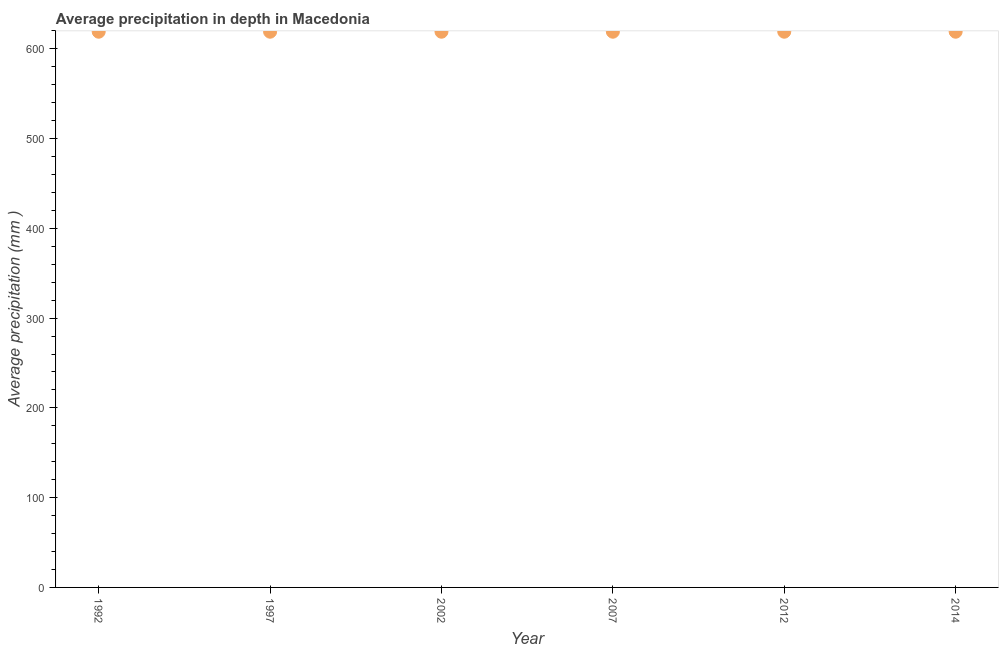What is the average precipitation in depth in 2012?
Offer a very short reply. 619. Across all years, what is the maximum average precipitation in depth?
Make the answer very short. 619. Across all years, what is the minimum average precipitation in depth?
Offer a very short reply. 619. In which year was the average precipitation in depth maximum?
Give a very brief answer. 1992. In which year was the average precipitation in depth minimum?
Your answer should be compact. 1992. What is the sum of the average precipitation in depth?
Make the answer very short. 3714. What is the difference between the average precipitation in depth in 1997 and 2014?
Provide a short and direct response. 0. What is the average average precipitation in depth per year?
Ensure brevity in your answer.  619. What is the median average precipitation in depth?
Provide a succinct answer. 619. In how many years, is the average precipitation in depth greater than 120 mm?
Offer a very short reply. 6. What is the difference between the highest and the second highest average precipitation in depth?
Give a very brief answer. 0. Is the sum of the average precipitation in depth in 1992 and 2012 greater than the maximum average precipitation in depth across all years?
Provide a succinct answer. Yes. What is the difference between the highest and the lowest average precipitation in depth?
Offer a very short reply. 0. In how many years, is the average precipitation in depth greater than the average average precipitation in depth taken over all years?
Your answer should be very brief. 0. Are the values on the major ticks of Y-axis written in scientific E-notation?
Your answer should be very brief. No. Does the graph contain any zero values?
Provide a succinct answer. No. What is the title of the graph?
Your answer should be compact. Average precipitation in depth in Macedonia. What is the label or title of the X-axis?
Provide a succinct answer. Year. What is the label or title of the Y-axis?
Your answer should be very brief. Average precipitation (mm ). What is the Average precipitation (mm ) in 1992?
Your answer should be compact. 619. What is the Average precipitation (mm ) in 1997?
Your answer should be compact. 619. What is the Average precipitation (mm ) in 2002?
Offer a very short reply. 619. What is the Average precipitation (mm ) in 2007?
Your answer should be very brief. 619. What is the Average precipitation (mm ) in 2012?
Offer a very short reply. 619. What is the Average precipitation (mm ) in 2014?
Make the answer very short. 619. What is the difference between the Average precipitation (mm ) in 1992 and 1997?
Your answer should be compact. 0. What is the difference between the Average precipitation (mm ) in 1992 and 2002?
Provide a short and direct response. 0. What is the difference between the Average precipitation (mm ) in 1992 and 2007?
Your response must be concise. 0. What is the difference between the Average precipitation (mm ) in 1992 and 2014?
Make the answer very short. 0. What is the difference between the Average precipitation (mm ) in 1997 and 2007?
Your response must be concise. 0. What is the difference between the Average precipitation (mm ) in 1997 and 2012?
Give a very brief answer. 0. What is the difference between the Average precipitation (mm ) in 2002 and 2014?
Offer a very short reply. 0. What is the difference between the Average precipitation (mm ) in 2007 and 2012?
Offer a very short reply. 0. What is the difference between the Average precipitation (mm ) in 2012 and 2014?
Your answer should be very brief. 0. What is the ratio of the Average precipitation (mm ) in 1992 to that in 1997?
Make the answer very short. 1. What is the ratio of the Average precipitation (mm ) in 1992 to that in 2002?
Give a very brief answer. 1. What is the ratio of the Average precipitation (mm ) in 1992 to that in 2012?
Keep it short and to the point. 1. What is the ratio of the Average precipitation (mm ) in 1997 to that in 2007?
Make the answer very short. 1. What is the ratio of the Average precipitation (mm ) in 1997 to that in 2014?
Make the answer very short. 1. What is the ratio of the Average precipitation (mm ) in 2002 to that in 2007?
Ensure brevity in your answer.  1. What is the ratio of the Average precipitation (mm ) in 2007 to that in 2012?
Your response must be concise. 1. What is the ratio of the Average precipitation (mm ) in 2007 to that in 2014?
Give a very brief answer. 1. What is the ratio of the Average precipitation (mm ) in 2012 to that in 2014?
Offer a terse response. 1. 